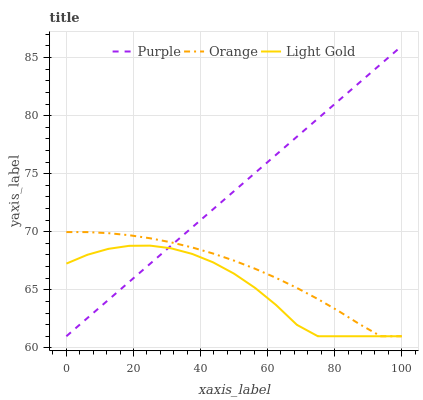Does Light Gold have the minimum area under the curve?
Answer yes or no. Yes. Does Purple have the maximum area under the curve?
Answer yes or no. Yes. Does Orange have the minimum area under the curve?
Answer yes or no. No. Does Orange have the maximum area under the curve?
Answer yes or no. No. Is Purple the smoothest?
Answer yes or no. Yes. Is Light Gold the roughest?
Answer yes or no. Yes. Is Orange the smoothest?
Answer yes or no. No. Is Orange the roughest?
Answer yes or no. No. Does Purple have the lowest value?
Answer yes or no. Yes. Does Purple have the highest value?
Answer yes or no. Yes. Does Orange have the highest value?
Answer yes or no. No. Does Light Gold intersect Purple?
Answer yes or no. Yes. Is Light Gold less than Purple?
Answer yes or no. No. Is Light Gold greater than Purple?
Answer yes or no. No. 